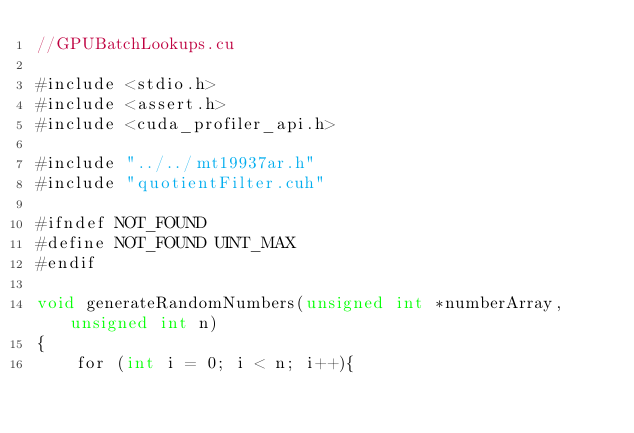Convert code to text. <code><loc_0><loc_0><loc_500><loc_500><_Cuda_>//GPUBatchLookups.cu

#include <stdio.h>
#include <assert.h>
#include <cuda_profiler_api.h>

#include "../../mt19937ar.h"
#include "quotientFilter.cuh"

#ifndef NOT_FOUND
#define NOT_FOUND UINT_MAX
#endif

void generateRandomNumbers(unsigned int *numberArray, unsigned int n)
{
    for (int i = 0; i < n; i++){</code> 